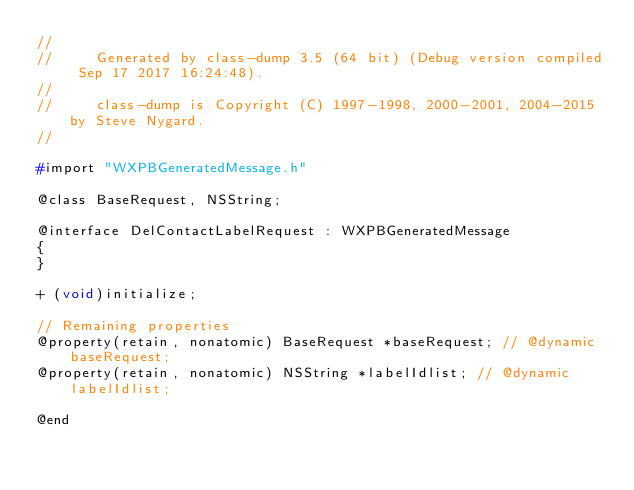Convert code to text. <code><loc_0><loc_0><loc_500><loc_500><_C_>//
//     Generated by class-dump 3.5 (64 bit) (Debug version compiled Sep 17 2017 16:24:48).
//
//     class-dump is Copyright (C) 1997-1998, 2000-2001, 2004-2015 by Steve Nygard.
//

#import "WXPBGeneratedMessage.h"

@class BaseRequest, NSString;

@interface DelContactLabelRequest : WXPBGeneratedMessage
{
}

+ (void)initialize;

// Remaining properties
@property(retain, nonatomic) BaseRequest *baseRequest; // @dynamic baseRequest;
@property(retain, nonatomic) NSString *labelIdlist; // @dynamic labelIdlist;

@end

</code> 